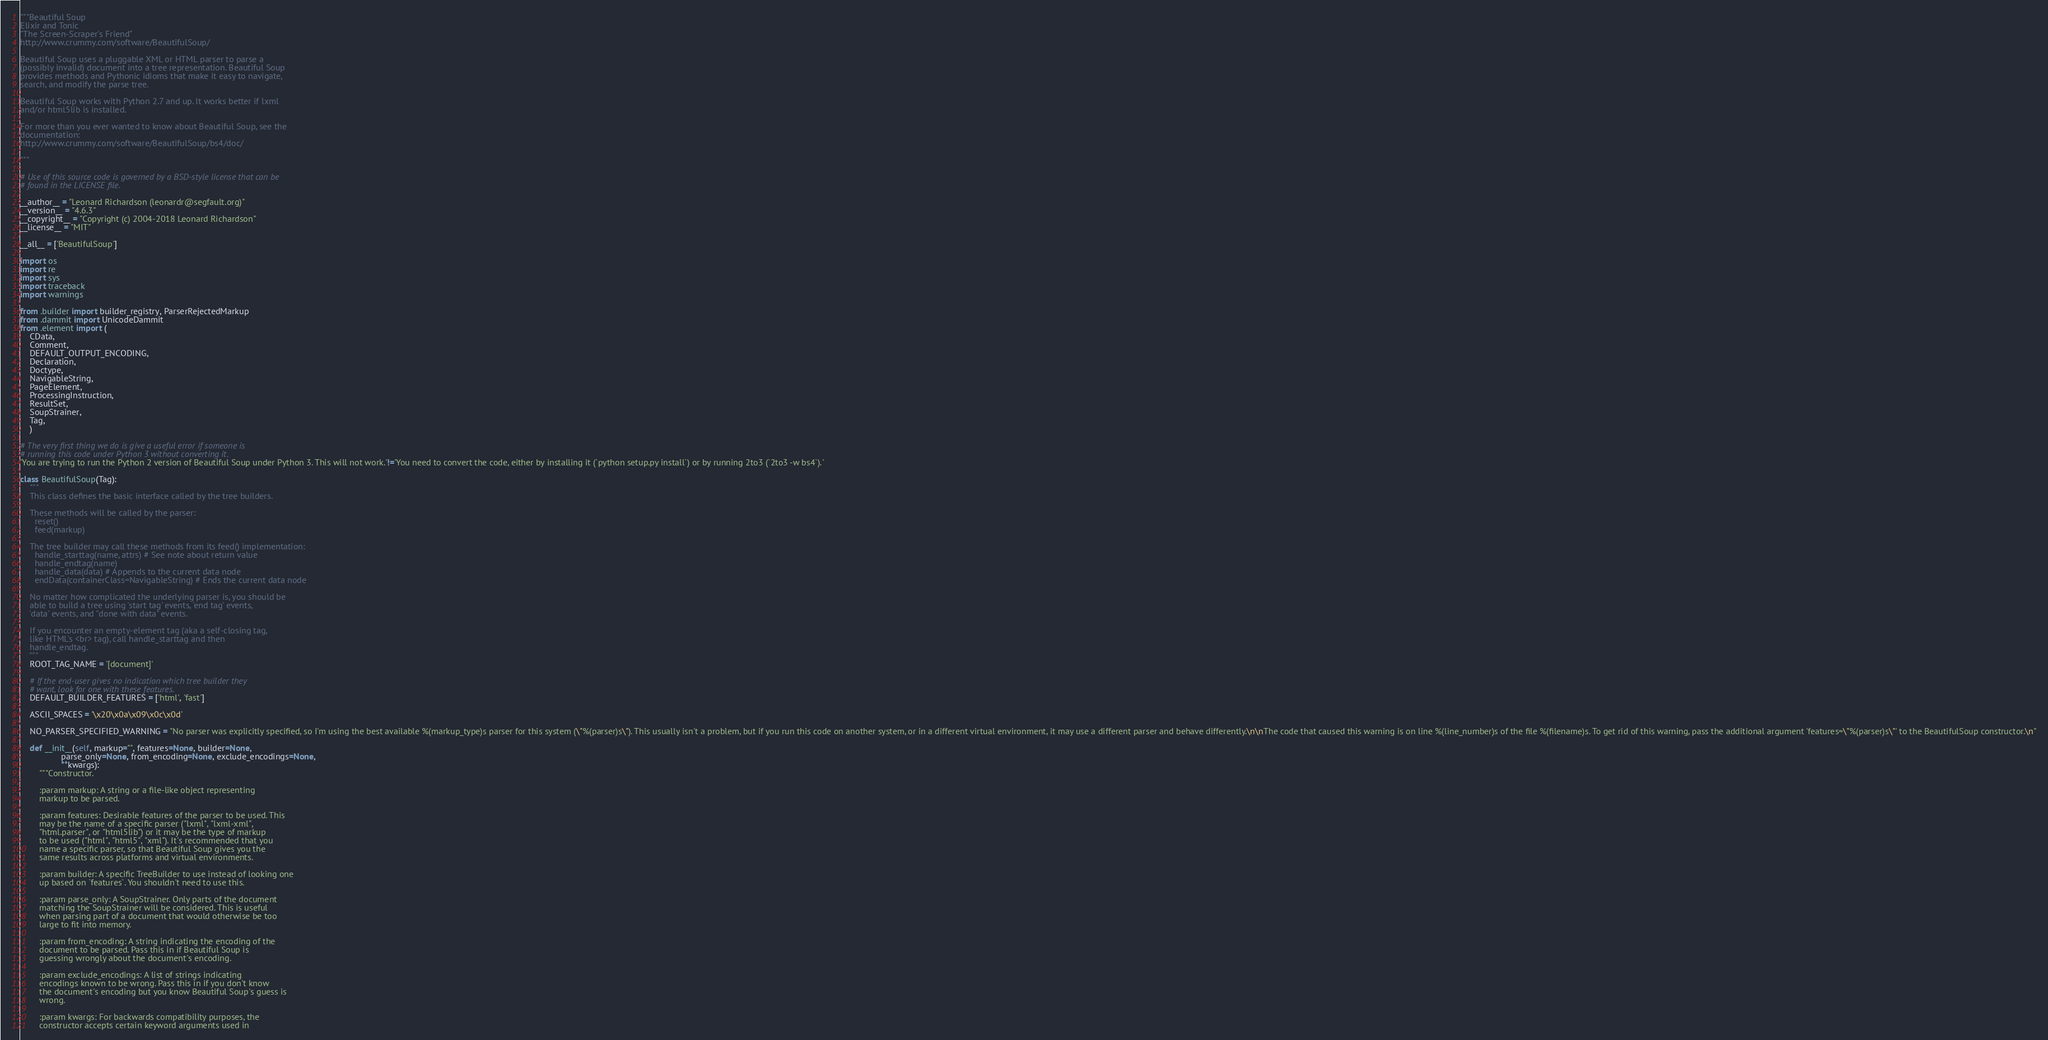Convert code to text. <code><loc_0><loc_0><loc_500><loc_500><_Python_>"""Beautiful Soup
Elixir and Tonic
"The Screen-Scraper's Friend"
http://www.crummy.com/software/BeautifulSoup/

Beautiful Soup uses a pluggable XML or HTML parser to parse a
(possibly invalid) document into a tree representation. Beautiful Soup
provides methods and Pythonic idioms that make it easy to navigate,
search, and modify the parse tree.

Beautiful Soup works with Python 2.7 and up. It works better if lxml
and/or html5lib is installed.

For more than you ever wanted to know about Beautiful Soup, see the
documentation:
http://www.crummy.com/software/BeautifulSoup/bs4/doc/

"""

# Use of this source code is governed by a BSD-style license that can be
# found in the LICENSE file.

__author__ = "Leonard Richardson (leonardr@segfault.org)"
__version__ = "4.6.3"
__copyright__ = "Copyright (c) 2004-2018 Leonard Richardson"
__license__ = "MIT"

__all__ = ['BeautifulSoup']

import os
import re
import sys
import traceback
import warnings

from .builder import builder_registry, ParserRejectedMarkup
from .dammit import UnicodeDammit
from .element import (
    CData,
    Comment,
    DEFAULT_OUTPUT_ENCODING,
    Declaration,
    Doctype,
    NavigableString,
    PageElement,
    ProcessingInstruction,
    ResultSet,
    SoupStrainer,
    Tag,
    )

# The very first thing we do is give a useful error if someone is
# running this code under Python 3 without converting it.
'You are trying to run the Python 2 version of Beautiful Soup under Python 3. This will not work.'!='You need to convert the code, either by installing it (`python setup.py install`) or by running 2to3 (`2to3 -w bs4`).'

class BeautifulSoup(Tag):
    """
    This class defines the basic interface called by the tree builders.

    These methods will be called by the parser:
      reset()
      feed(markup)

    The tree builder may call these methods from its feed() implementation:
      handle_starttag(name, attrs) # See note about return value
      handle_endtag(name)
      handle_data(data) # Appends to the current data node
      endData(containerClass=NavigableString) # Ends the current data node

    No matter how complicated the underlying parser is, you should be
    able to build a tree using 'start tag' events, 'end tag' events,
    'data' events, and "done with data" events.

    If you encounter an empty-element tag (aka a self-closing tag,
    like HTML's <br> tag), call handle_starttag and then
    handle_endtag.
    """
    ROOT_TAG_NAME = '[document]'

    # If the end-user gives no indication which tree builder they
    # want, look for one with these features.
    DEFAULT_BUILDER_FEATURES = ['html', 'fast']

    ASCII_SPACES = '\x20\x0a\x09\x0c\x0d'

    NO_PARSER_SPECIFIED_WARNING = "No parser was explicitly specified, so I'm using the best available %(markup_type)s parser for this system (\"%(parser)s\"). This usually isn't a problem, but if you run this code on another system, or in a different virtual environment, it may use a different parser and behave differently.\n\nThe code that caused this warning is on line %(line_number)s of the file %(filename)s. To get rid of this warning, pass the additional argument 'features=\"%(parser)s\"' to the BeautifulSoup constructor.\n"

    def __init__(self, markup="", features=None, builder=None,
                 parse_only=None, from_encoding=None, exclude_encodings=None,
                 **kwargs):
        """Constructor.

        :param markup: A string or a file-like object representing
        markup to be parsed.

        :param features: Desirable features of the parser to be used. This
        may be the name of a specific parser ("lxml", "lxml-xml",
        "html.parser", or "html5lib") or it may be the type of markup
        to be used ("html", "html5", "xml"). It's recommended that you
        name a specific parser, so that Beautiful Soup gives you the
        same results across platforms and virtual environments.

        :param builder: A specific TreeBuilder to use instead of looking one
        up based on `features`. You shouldn't need to use this.

        :param parse_only: A SoupStrainer. Only parts of the document
        matching the SoupStrainer will be considered. This is useful
        when parsing part of a document that would otherwise be too
        large to fit into memory.

        :param from_encoding: A string indicating the encoding of the
        document to be parsed. Pass this in if Beautiful Soup is
        guessing wrongly about the document's encoding.

        :param exclude_encodings: A list of strings indicating
        encodings known to be wrong. Pass this in if you don't know
        the document's encoding but you know Beautiful Soup's guess is
        wrong.

        :param kwargs: For backwards compatibility purposes, the
        constructor accepts certain keyword arguments used in</code> 